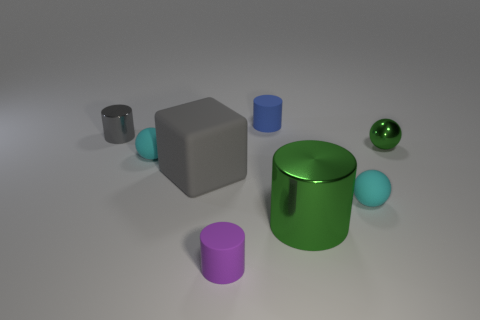What is the size of the purple object that is the same material as the blue thing?
Your response must be concise. Small. Do the cyan ball that is left of the blue thing and the small cyan object on the right side of the small blue matte thing have the same material?
Give a very brief answer. Yes. What number of blocks are either blue matte objects or gray objects?
Make the answer very short. 1. What number of large green cylinders are right of the small matte sphere to the left of the rubber cylinder that is in front of the gray cylinder?
Give a very brief answer. 1. There is a small purple object that is the same shape as the blue object; what is it made of?
Offer a very short reply. Rubber. There is a cylinder on the left side of the purple matte cylinder; what is its color?
Make the answer very short. Gray. Do the cube and the cylinder right of the small blue matte cylinder have the same material?
Ensure brevity in your answer.  No. What material is the tiny blue cylinder?
Ensure brevity in your answer.  Rubber. What shape is the small gray object that is the same material as the green ball?
Offer a terse response. Cylinder. What number of other things are the same shape as the large green shiny thing?
Offer a terse response. 3. 